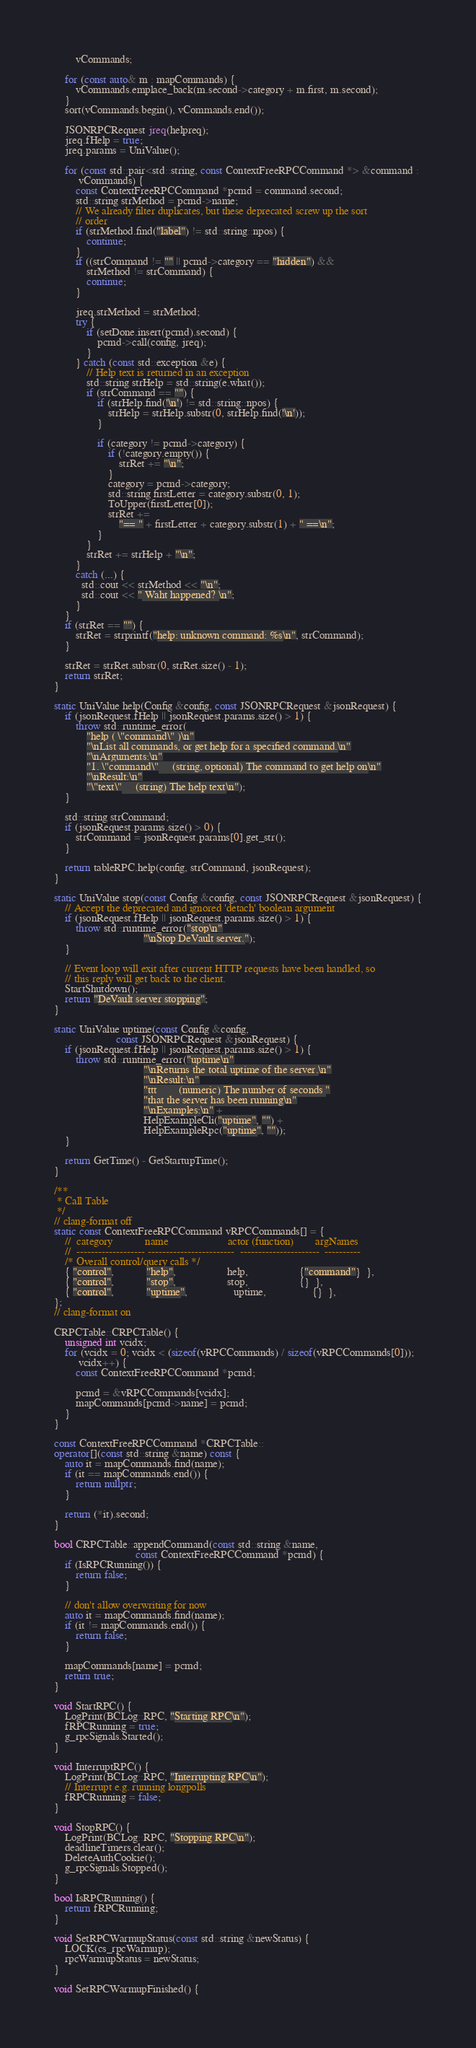<code> <loc_0><loc_0><loc_500><loc_500><_C++_>        vCommands;

    for (const auto& m : mapCommands) {
        vCommands.emplace_back(m.second->category + m.first, m.second);
    }
    sort(vCommands.begin(), vCommands.end());

    JSONRPCRequest jreq(helpreq);
    jreq.fHelp = true;
    jreq.params = UniValue();

    for (const std::pair<std::string, const ContextFreeRPCCommand *> &command :
         vCommands) {
        const ContextFreeRPCCommand *pcmd = command.second;
        std::string strMethod = pcmd->name;
        // We already filter duplicates, but these deprecated screw up the sort
        // order
        if (strMethod.find("label") != std::string::npos) {
            continue;
        }
        if ((strCommand != "" || pcmd->category == "hidden") &&
            strMethod != strCommand) {
            continue;
        }

        jreq.strMethod = strMethod;
        try {
            if (setDone.insert(pcmd).second) {
                pcmd->call(config, jreq);
            }
        } catch (const std::exception &e) {
            // Help text is returned in an exception
            std::string strHelp = std::string(e.what());
            if (strCommand == "") {
                if (strHelp.find('\n') != std::string::npos) {
                    strHelp = strHelp.substr(0, strHelp.find('\n'));
                }

                if (category != pcmd->category) {
                    if (!category.empty()) {
                        strRet += "\n";
                    }
                    category = pcmd->category;
                    std::string firstLetter = category.substr(0, 1);
                    ToUpper(firstLetter[0]);
                    strRet +=
                        "== " + firstLetter + category.substr(1) + " ==\n";
                }
            }
            strRet += strHelp + "\n";
        }
        catch (...) {
          std::cout << strMethod << "\n";
          std::cout << " Waht happened? \n";
        }
    }
    if (strRet == "") {
        strRet = strprintf("help: unknown command: %s\n", strCommand);
    }

    strRet = strRet.substr(0, strRet.size() - 1);
    return strRet;
}

static UniValue help(Config &config, const JSONRPCRequest &jsonRequest) {
    if (jsonRequest.fHelp || jsonRequest.params.size() > 1) {
        throw std::runtime_error(
            "help ( \"command\" )\n"
            "\nList all commands, or get help for a specified command.\n"
            "\nArguments:\n"
            "1. \"command\"     (string, optional) The command to get help on\n"
            "\nResult:\n"
            "\"text\"     (string) The help text\n");
    }

    std::string strCommand;
    if (jsonRequest.params.size() > 0) {
        strCommand = jsonRequest.params[0].get_str();
    }

    return tableRPC.help(config, strCommand, jsonRequest);
}

static UniValue stop(const Config &config, const JSONRPCRequest &jsonRequest) {
    // Accept the deprecated and ignored 'detach' boolean argument
    if (jsonRequest.fHelp || jsonRequest.params.size() > 1) {
        throw std::runtime_error("stop\n"
                                 "\nStop DeVault server.");
    }

    // Event loop will exit after current HTTP requests have been handled, so
    // this reply will get back to the client.
    StartShutdown();
    return "DeVault server stopping";
}

static UniValue uptime(const Config &config,
                       const JSONRPCRequest &jsonRequest) {
    if (jsonRequest.fHelp || jsonRequest.params.size() > 1) {
        throw std::runtime_error("uptime\n"
                                 "\nReturns the total uptime of the server.\n"
                                 "\nResult:\n"
                                 "ttt        (numeric) The number of seconds "
                                 "that the server has been running\n"
                                 "\nExamples:\n" +
                                 HelpExampleCli("uptime", "") +
                                 HelpExampleRpc("uptime", ""));
    }

    return GetTime() - GetStartupTime();
}

/**
 * Call Table
 */
// clang-format off
static const ContextFreeRPCCommand vRPCCommands[] = {
    //  category            name                      actor (function)        argNames
    //  ------------------- ------------------------  ----------------------  ----------
    /* Overall control/query calls */
    { "control",            "help",                   help,                   {"command"}  },
    { "control",            "stop",                   stop,                   {}  },
    { "control",            "uptime",                 uptime,                 {}  },
};
// clang-format on

CRPCTable::CRPCTable() {
    unsigned int vcidx;
    for (vcidx = 0; vcidx < (sizeof(vRPCCommands) / sizeof(vRPCCommands[0]));
         vcidx++) {
        const ContextFreeRPCCommand *pcmd;

        pcmd = &vRPCCommands[vcidx];
        mapCommands[pcmd->name] = pcmd;
    }
}

const ContextFreeRPCCommand *CRPCTable::
operator[](const std::string &name) const {
    auto it = mapCommands.find(name);
    if (it == mapCommands.end()) {
        return nullptr;
    }

    return (*it).second;
}

bool CRPCTable::appendCommand(const std::string &name,
                              const ContextFreeRPCCommand *pcmd) {
    if (IsRPCRunning()) {
        return false;
    }

    // don't allow overwriting for now
    auto it = mapCommands.find(name);
    if (it != mapCommands.end()) {
        return false;
    }

    mapCommands[name] = pcmd;
    return true;
}

void StartRPC() {
    LogPrint(BCLog::RPC, "Starting RPC\n");
    fRPCRunning = true;
    g_rpcSignals.Started();
}

void InterruptRPC() {
    LogPrint(BCLog::RPC, "Interrupting RPC\n");
    // Interrupt e.g. running longpolls
    fRPCRunning = false;
}

void StopRPC() {
    LogPrint(BCLog::RPC, "Stopping RPC\n");
    deadlineTimers.clear();
    DeleteAuthCookie();
    g_rpcSignals.Stopped();
}

bool IsRPCRunning() {
    return fRPCRunning;
}

void SetRPCWarmupStatus(const std::string &newStatus) {
    LOCK(cs_rpcWarmup);
    rpcWarmupStatus = newStatus;
}

void SetRPCWarmupFinished() {</code> 